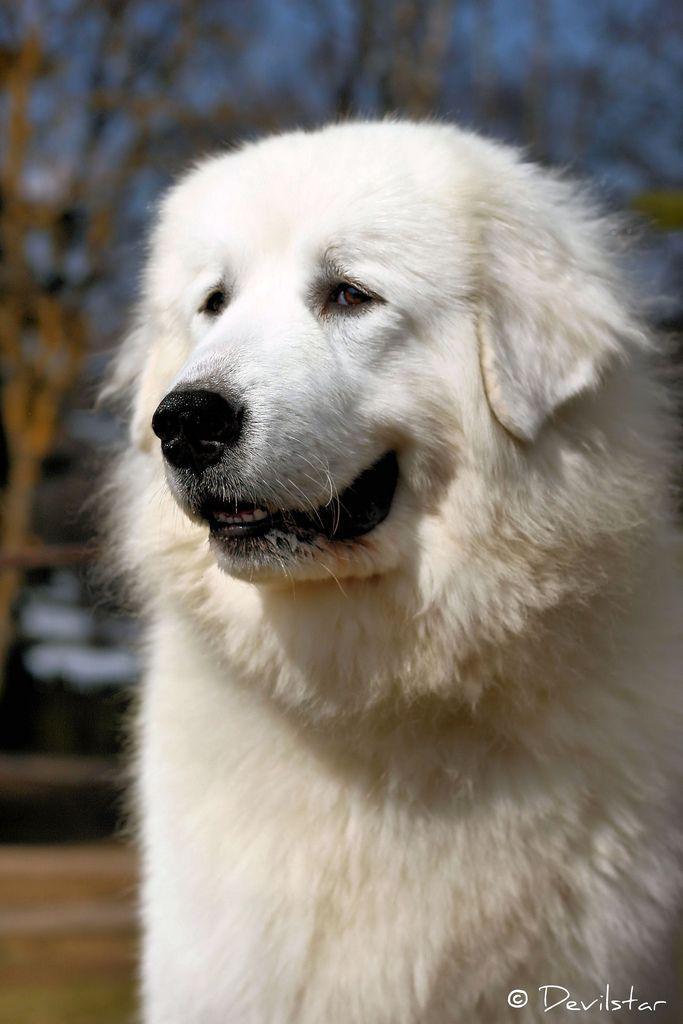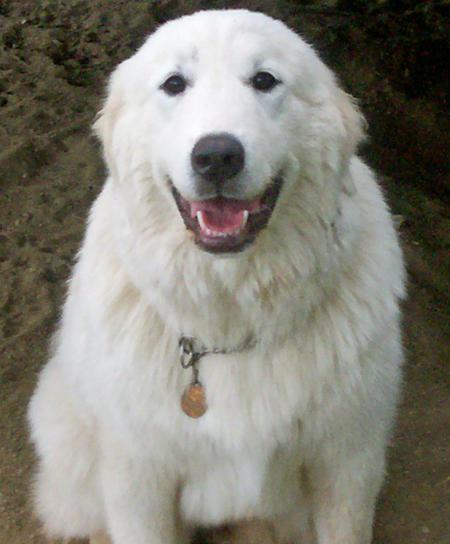The first image is the image on the left, the second image is the image on the right. Evaluate the accuracy of this statement regarding the images: "there is one dog in the left side pic". Is it true? Answer yes or no. Yes. The first image is the image on the left, the second image is the image on the right. For the images displayed, is the sentence "There are exactly two dogs." factually correct? Answer yes or no. Yes. 